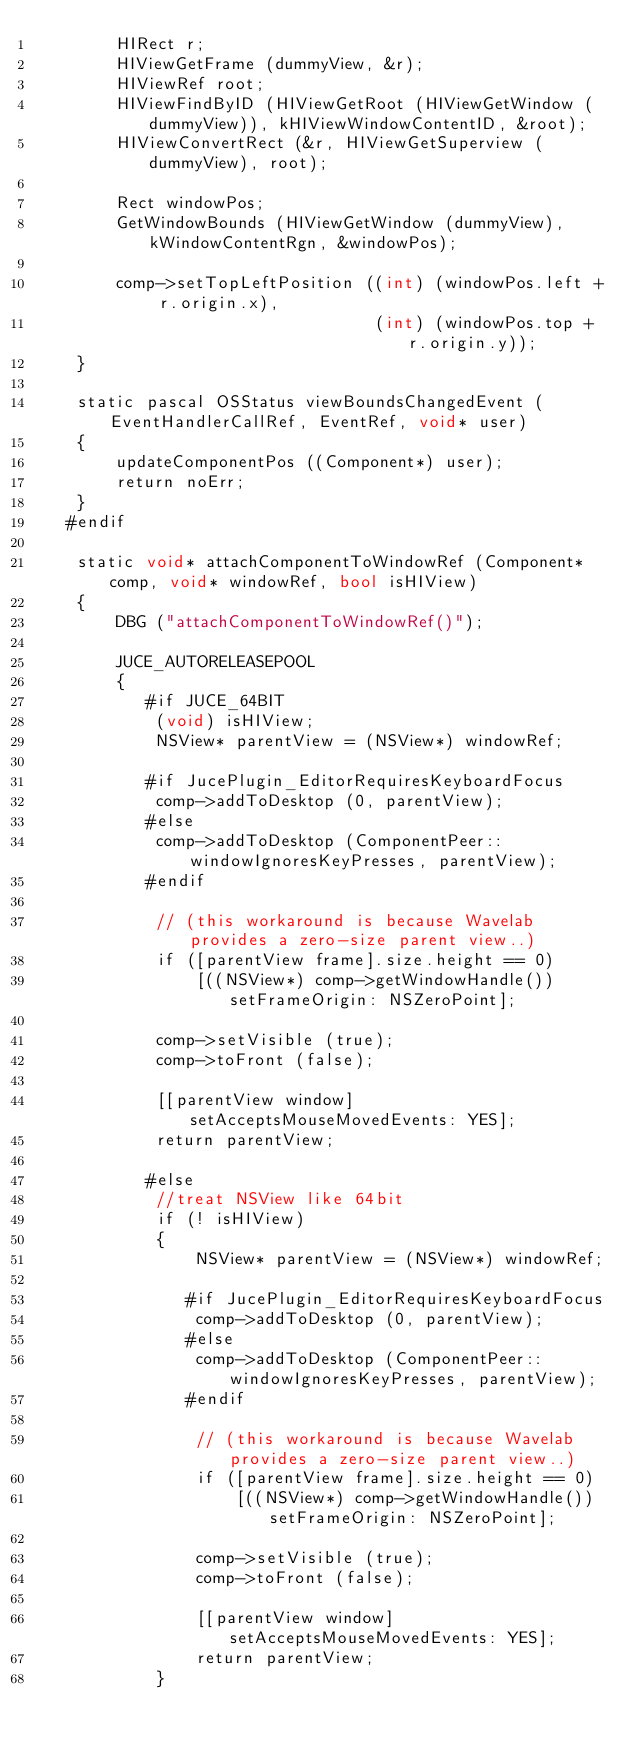<code> <loc_0><loc_0><loc_500><loc_500><_ObjectiveC_>        HIRect r;
        HIViewGetFrame (dummyView, &r);
        HIViewRef root;
        HIViewFindByID (HIViewGetRoot (HIViewGetWindow (dummyView)), kHIViewWindowContentID, &root);
        HIViewConvertRect (&r, HIViewGetSuperview (dummyView), root);

        Rect windowPos;
        GetWindowBounds (HIViewGetWindow (dummyView), kWindowContentRgn, &windowPos);

        comp->setTopLeftPosition ((int) (windowPos.left + r.origin.x),
                                  (int) (windowPos.top + r.origin.y));
    }

    static pascal OSStatus viewBoundsChangedEvent (EventHandlerCallRef, EventRef, void* user)
    {
        updateComponentPos ((Component*) user);
        return noErr;
    }
   #endif

    static void* attachComponentToWindowRef (Component* comp, void* windowRef, bool isHIView)
    {
        DBG ("attachComponentToWindowRef()");

        JUCE_AUTORELEASEPOOL
        {
           #if JUCE_64BIT
            (void) isHIView;
            NSView* parentView = (NSView*) windowRef;

           #if JucePlugin_EditorRequiresKeyboardFocus
            comp->addToDesktop (0, parentView);
           #else
            comp->addToDesktop (ComponentPeer::windowIgnoresKeyPresses, parentView);
           #endif

            // (this workaround is because Wavelab provides a zero-size parent view..)
            if ([parentView frame].size.height == 0)
                [((NSView*) comp->getWindowHandle()) setFrameOrigin: NSZeroPoint];

            comp->setVisible (true);
            comp->toFront (false);

            [[parentView window] setAcceptsMouseMovedEvents: YES];
            return parentView;

           #else
            //treat NSView like 64bit
            if (! isHIView)
            {
                NSView* parentView = (NSView*) windowRef;

               #if JucePlugin_EditorRequiresKeyboardFocus
                comp->addToDesktop (0, parentView);
               #else
                comp->addToDesktop (ComponentPeer::windowIgnoresKeyPresses, parentView);
               #endif

                // (this workaround is because Wavelab provides a zero-size parent view..)
                if ([parentView frame].size.height == 0)
                    [((NSView*) comp->getWindowHandle()) setFrameOrigin: NSZeroPoint];

                comp->setVisible (true);
                comp->toFront (false);

                [[parentView window] setAcceptsMouseMovedEvents: YES];
                return parentView;
            }
</code> 